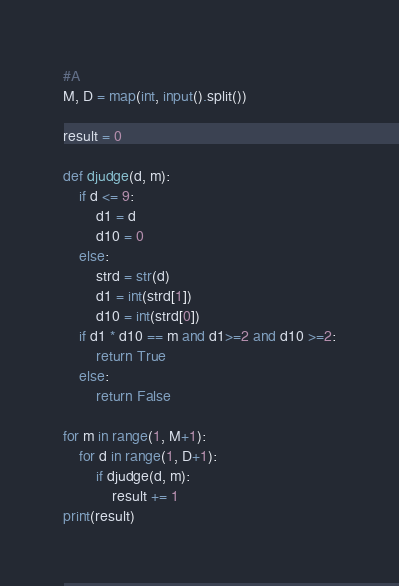<code> <loc_0><loc_0><loc_500><loc_500><_Python_>#A
M, D = map(int, input().split())

result = 0

def djudge(d, m):
    if d <= 9:
        d1 = d
        d10 = 0
    else:
        strd = str(d)
        d1 = int(strd[1])
        d10 = int(strd[0])
    if d1 * d10 == m and d1>=2 and d10 >=2:
        return True
    else:
        return False

for m in range(1, M+1):
    for d in range(1, D+1):
        if djudge(d, m):
            result += 1
print(result)</code> 